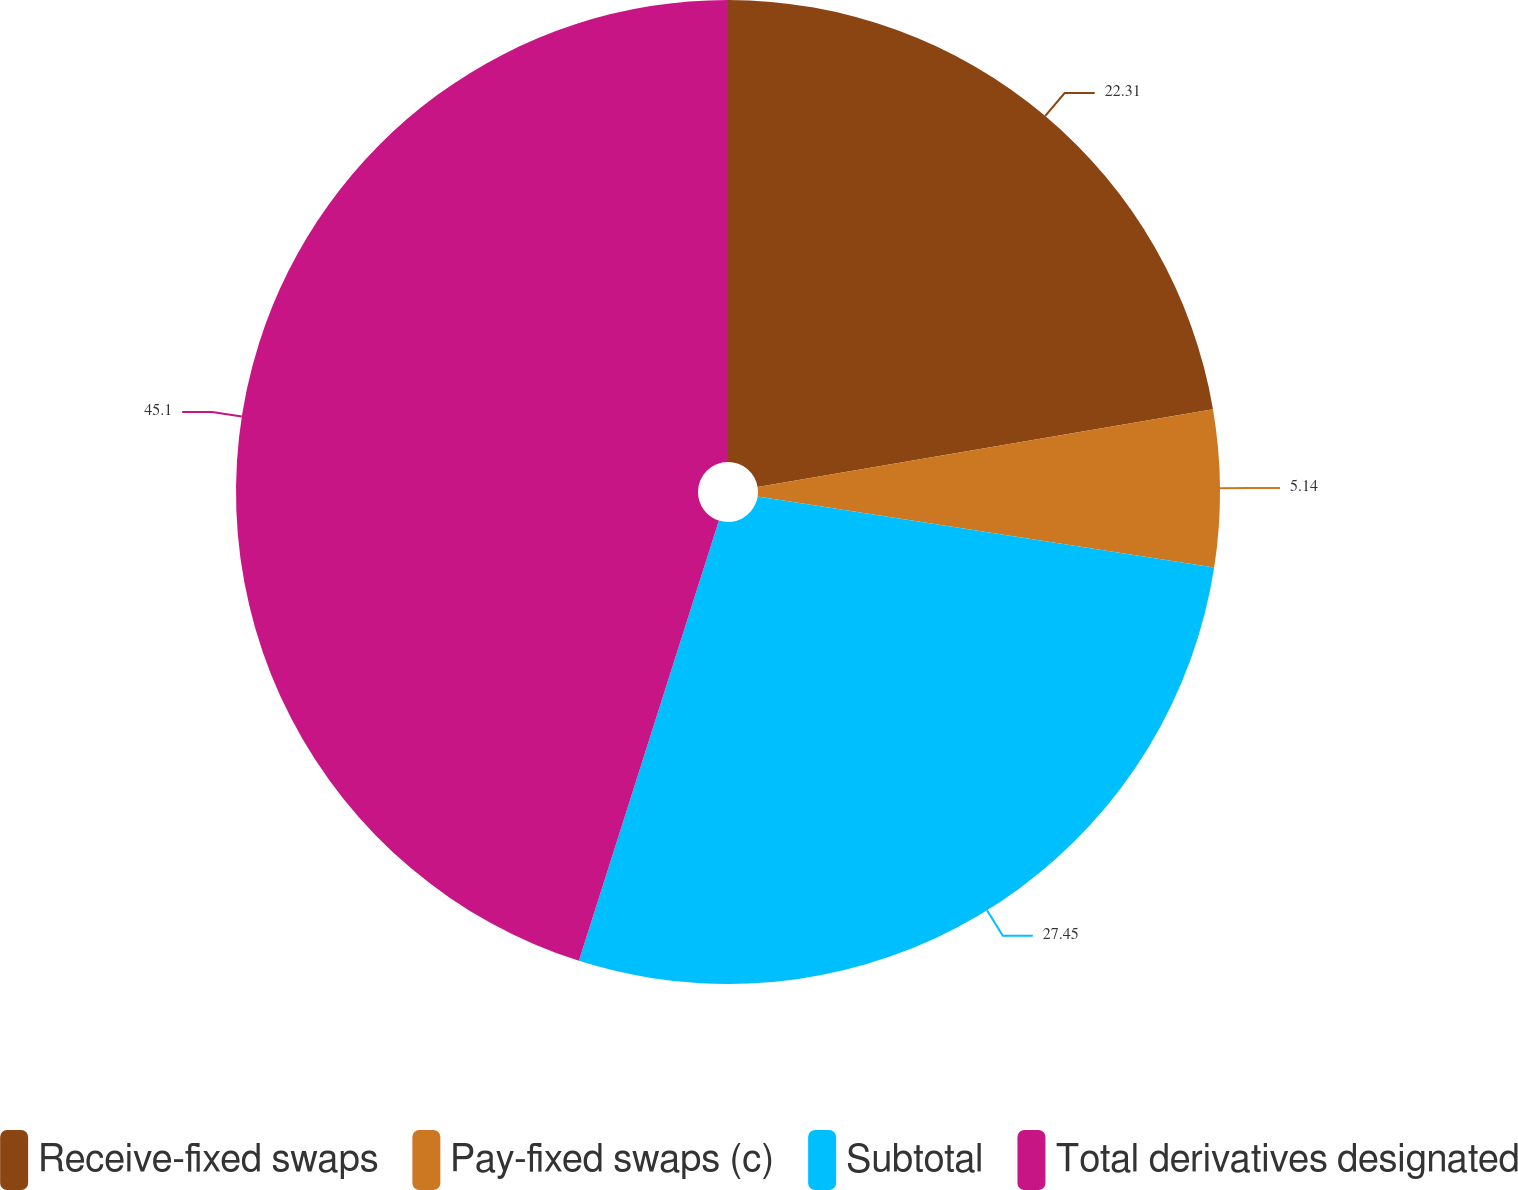Convert chart. <chart><loc_0><loc_0><loc_500><loc_500><pie_chart><fcel>Receive-fixed swaps<fcel>Pay-fixed swaps (c)<fcel>Subtotal<fcel>Total derivatives designated<nl><fcel>22.31%<fcel>5.14%<fcel>27.45%<fcel>45.1%<nl></chart> 